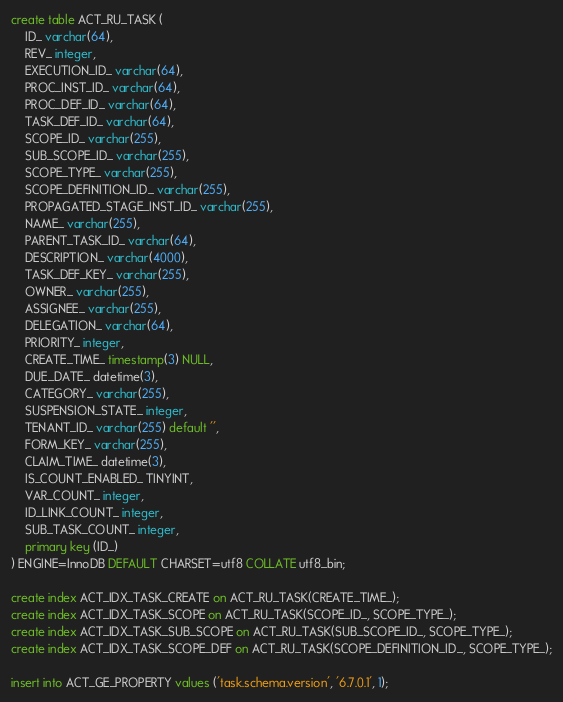Convert code to text. <code><loc_0><loc_0><loc_500><loc_500><_SQL_>create table ACT_RU_TASK (
    ID_ varchar(64),
    REV_ integer,
    EXECUTION_ID_ varchar(64),
    PROC_INST_ID_ varchar(64),
    PROC_DEF_ID_ varchar(64),
    TASK_DEF_ID_ varchar(64),
    SCOPE_ID_ varchar(255),
    SUB_SCOPE_ID_ varchar(255),
    SCOPE_TYPE_ varchar(255),
    SCOPE_DEFINITION_ID_ varchar(255),
    PROPAGATED_STAGE_INST_ID_ varchar(255),
    NAME_ varchar(255),
    PARENT_TASK_ID_ varchar(64),
    DESCRIPTION_ varchar(4000),
    TASK_DEF_KEY_ varchar(255),
    OWNER_ varchar(255),
    ASSIGNEE_ varchar(255),
    DELEGATION_ varchar(64),
    PRIORITY_ integer,
    CREATE_TIME_ timestamp(3) NULL,
    DUE_DATE_ datetime(3),
    CATEGORY_ varchar(255),
    SUSPENSION_STATE_ integer,
    TENANT_ID_ varchar(255) default '',
    FORM_KEY_ varchar(255),
    CLAIM_TIME_ datetime(3),
    IS_COUNT_ENABLED_ TINYINT,
    VAR_COUNT_ integer,
    ID_LINK_COUNT_ integer,
    SUB_TASK_COUNT_ integer,
    primary key (ID_)
) ENGINE=InnoDB DEFAULT CHARSET=utf8 COLLATE utf8_bin;

create index ACT_IDX_TASK_CREATE on ACT_RU_TASK(CREATE_TIME_);
create index ACT_IDX_TASK_SCOPE on ACT_RU_TASK(SCOPE_ID_, SCOPE_TYPE_);
create index ACT_IDX_TASK_SUB_SCOPE on ACT_RU_TASK(SUB_SCOPE_ID_, SCOPE_TYPE_);
create index ACT_IDX_TASK_SCOPE_DEF on ACT_RU_TASK(SCOPE_DEFINITION_ID_, SCOPE_TYPE_);

insert into ACT_GE_PROPERTY values ('task.schema.version', '6.7.0.1', 1);
</code> 